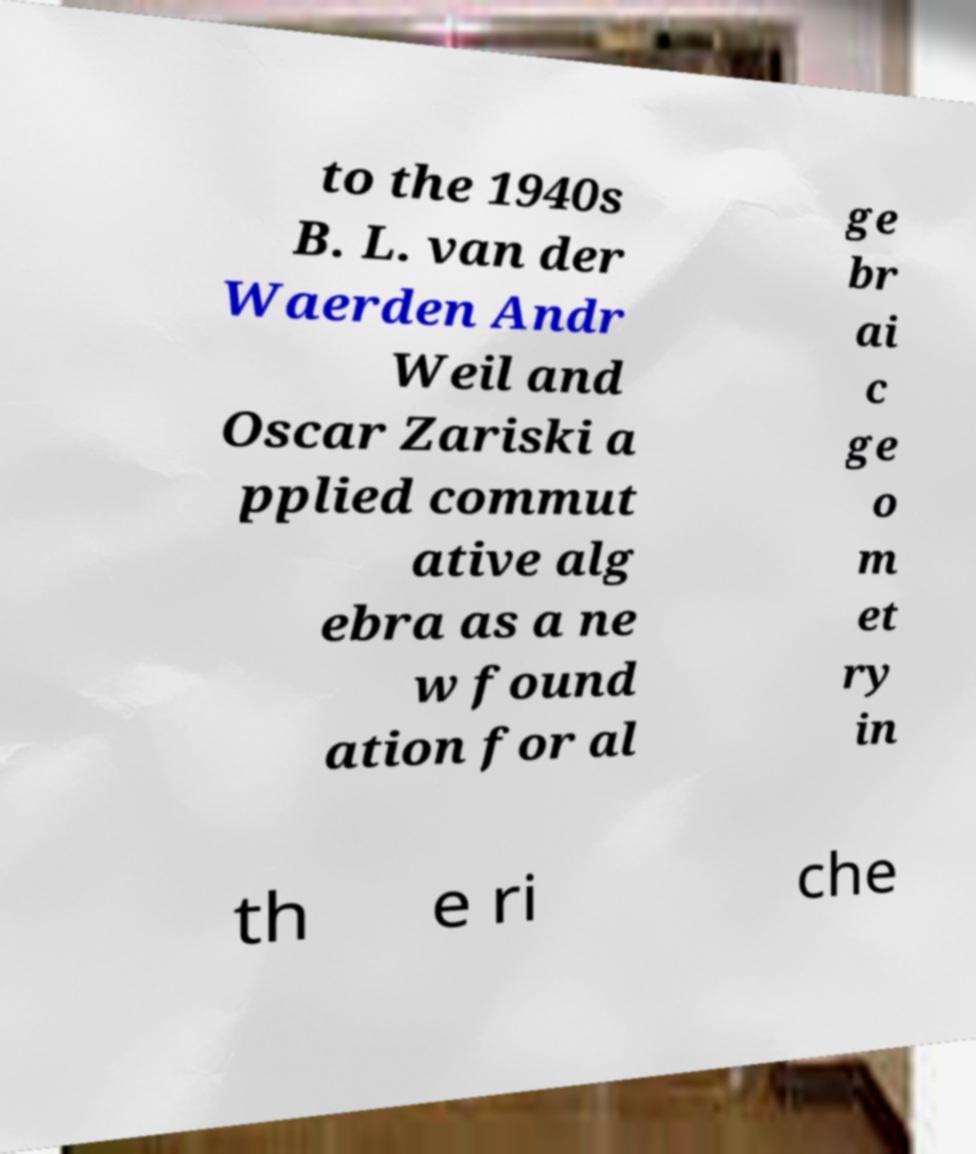Could you extract and type out the text from this image? to the 1940s B. L. van der Waerden Andr Weil and Oscar Zariski a pplied commut ative alg ebra as a ne w found ation for al ge br ai c ge o m et ry in th e ri che 